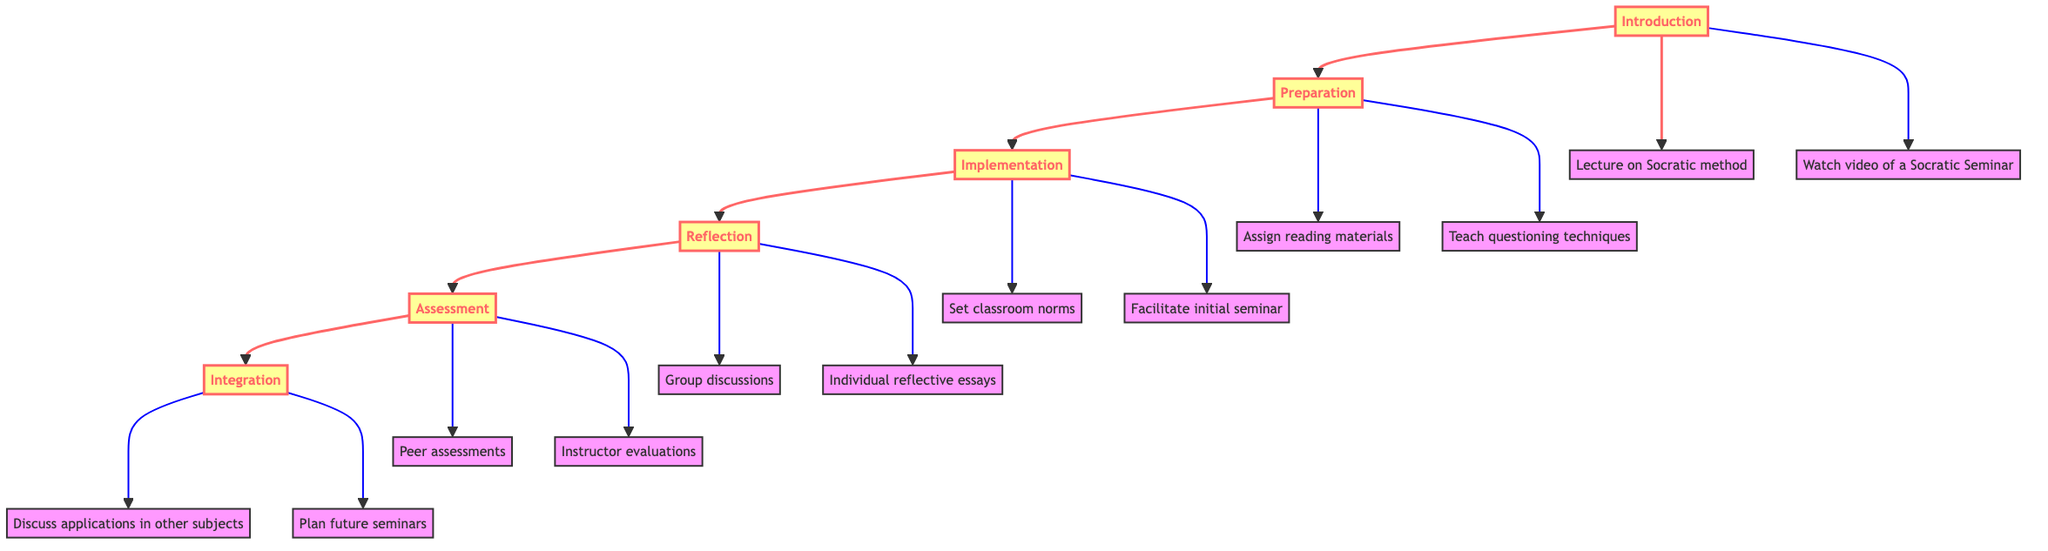What is the first level in the diagram? The first level in the diagram, representing the starting point of the instruction flow, is labeled "Introduction."
Answer: Introduction How many activities are listed under the "Implementation" level? Under the "Implementation" level, there are two activities listed: "Set classroom norms" and "Facilitate initial seminar." Therefore, the total number of activities is 2.
Answer: 2 What is the final level of the instruction flow? The final level of the instruction flow, where the last key activities occur, is labeled "Integration."
Answer: Integration What activities are suggested during the "Reflection" level? The "Reflection" level suggests two activities: "Group discussions" and "Individual reflective essays," providing insights on the seminar experience.
Answer: Group discussions, Individual reflective essays Which level comes immediately after "Preparation"? The level that follows "Preparation" in the flowchart is "Implementation," which outlines how to conduct the seminar after preparing students.
Answer: Implementation Which two resources can be found in the "Introduction" level? In the "Introduction" level, two resources are identified: "Books on Socratic Method" and "Online seminars and TED Talks," assisting in understanding the Socratic concepts.
Answer: Books on Socratic Method, Online seminars and TED Talks What is the purpose of the "Assessment" level? The "Assessment" level serves the purpose of evaluating student participation and learning following the Socratic Seminar, emphasizing the importance of student engagement.
Answer: Evaluate student participation and learning Which level involves discussing applications of the Socratic method in other subjects? The "Integration" level involves discussing applications of the Socratic method in other subjects as part of embedding it into a broader curriculum.
Answer: Integration What activities occur under the "Assessment" level? The "Assessment" level includes two main activities: "Peer assessments" and "Instructor evaluations," focusing on measuring student learning and participation.
Answer: Peer assessments, Instructor evaluations 